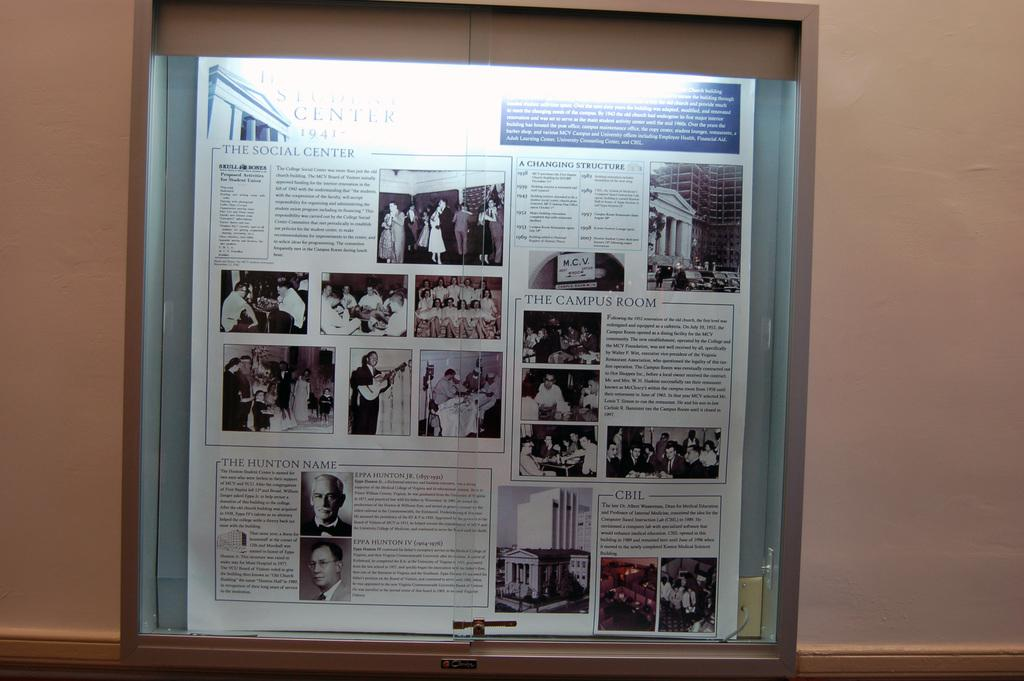<image>
Give a short and clear explanation of the subsequent image. A book is open to a page with the headline A changing structure. 